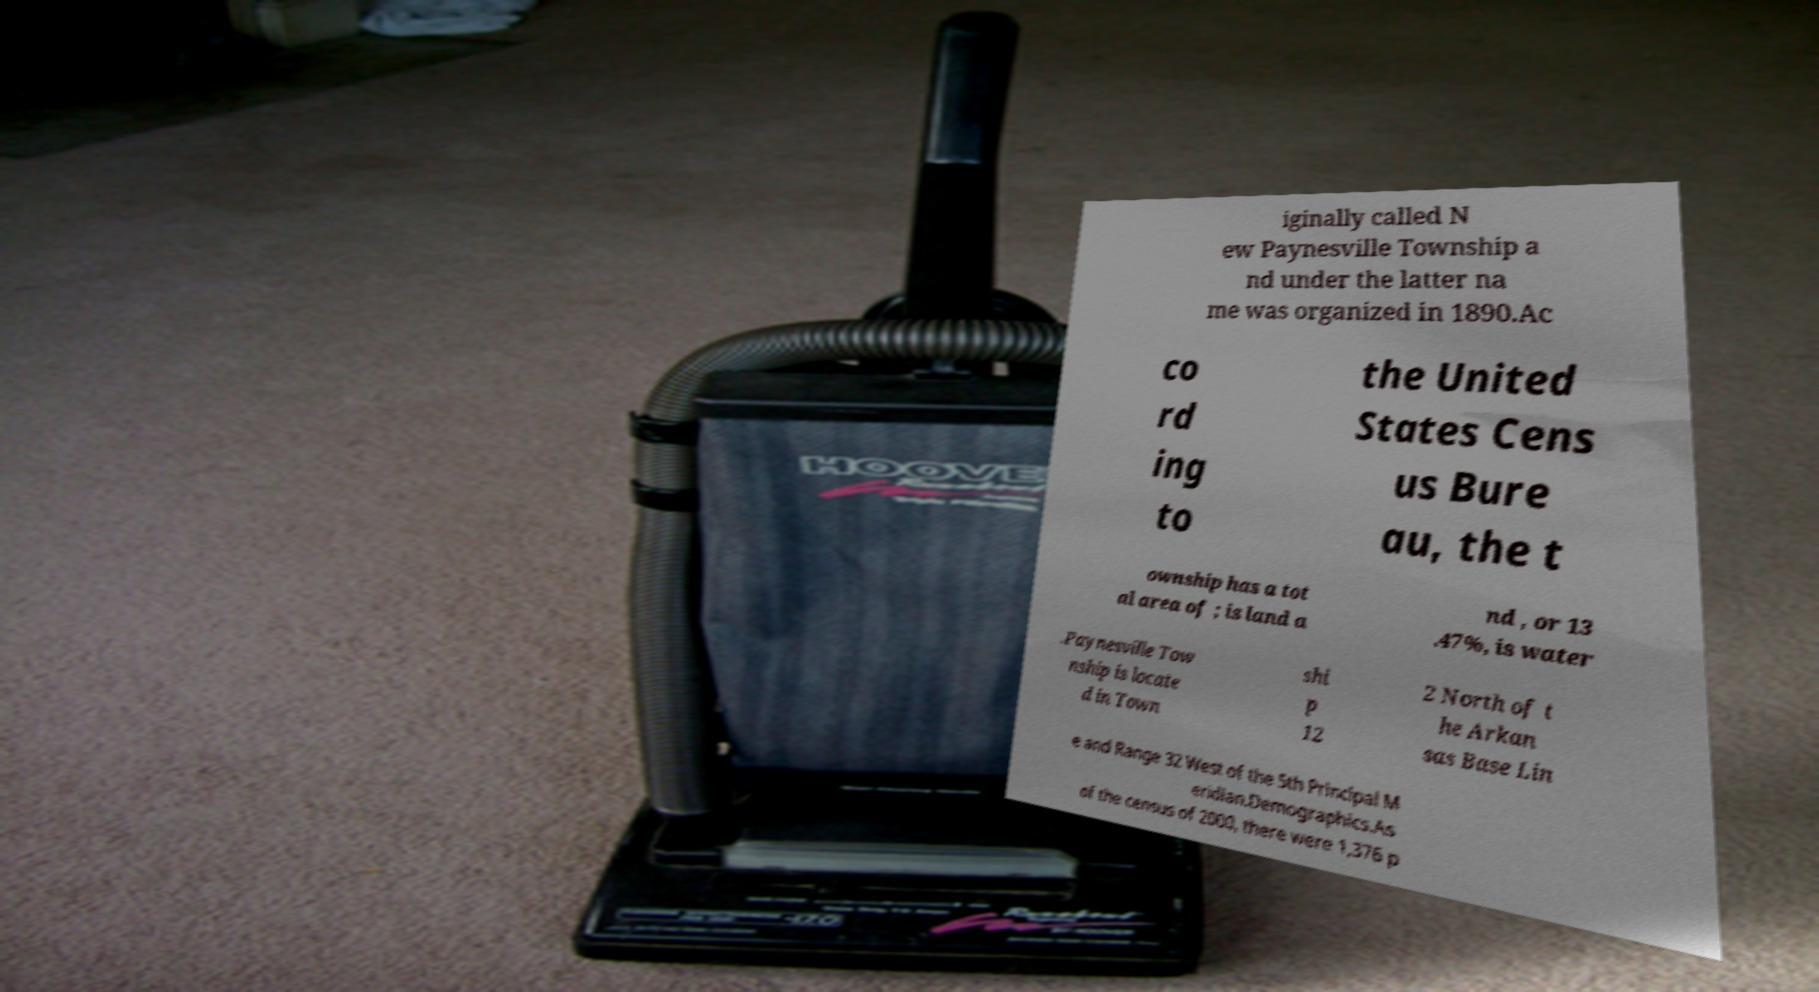Please read and relay the text visible in this image. What does it say? iginally called N ew Paynesville Township a nd under the latter na me was organized in 1890.Ac co rd ing to the United States Cens us Bure au, the t ownship has a tot al area of ; is land a nd , or 13 .47%, is water .Paynesville Tow nship is locate d in Town shi p 12 2 North of t he Arkan sas Base Lin e and Range 32 West of the 5th Principal M eridian.Demographics.As of the census of 2000, there were 1,376 p 